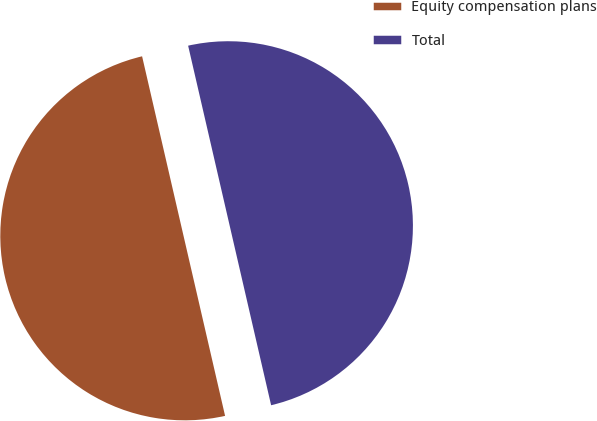<chart> <loc_0><loc_0><loc_500><loc_500><pie_chart><fcel>Equity compensation plans<fcel>Total<nl><fcel>50.0%<fcel>50.0%<nl></chart> 